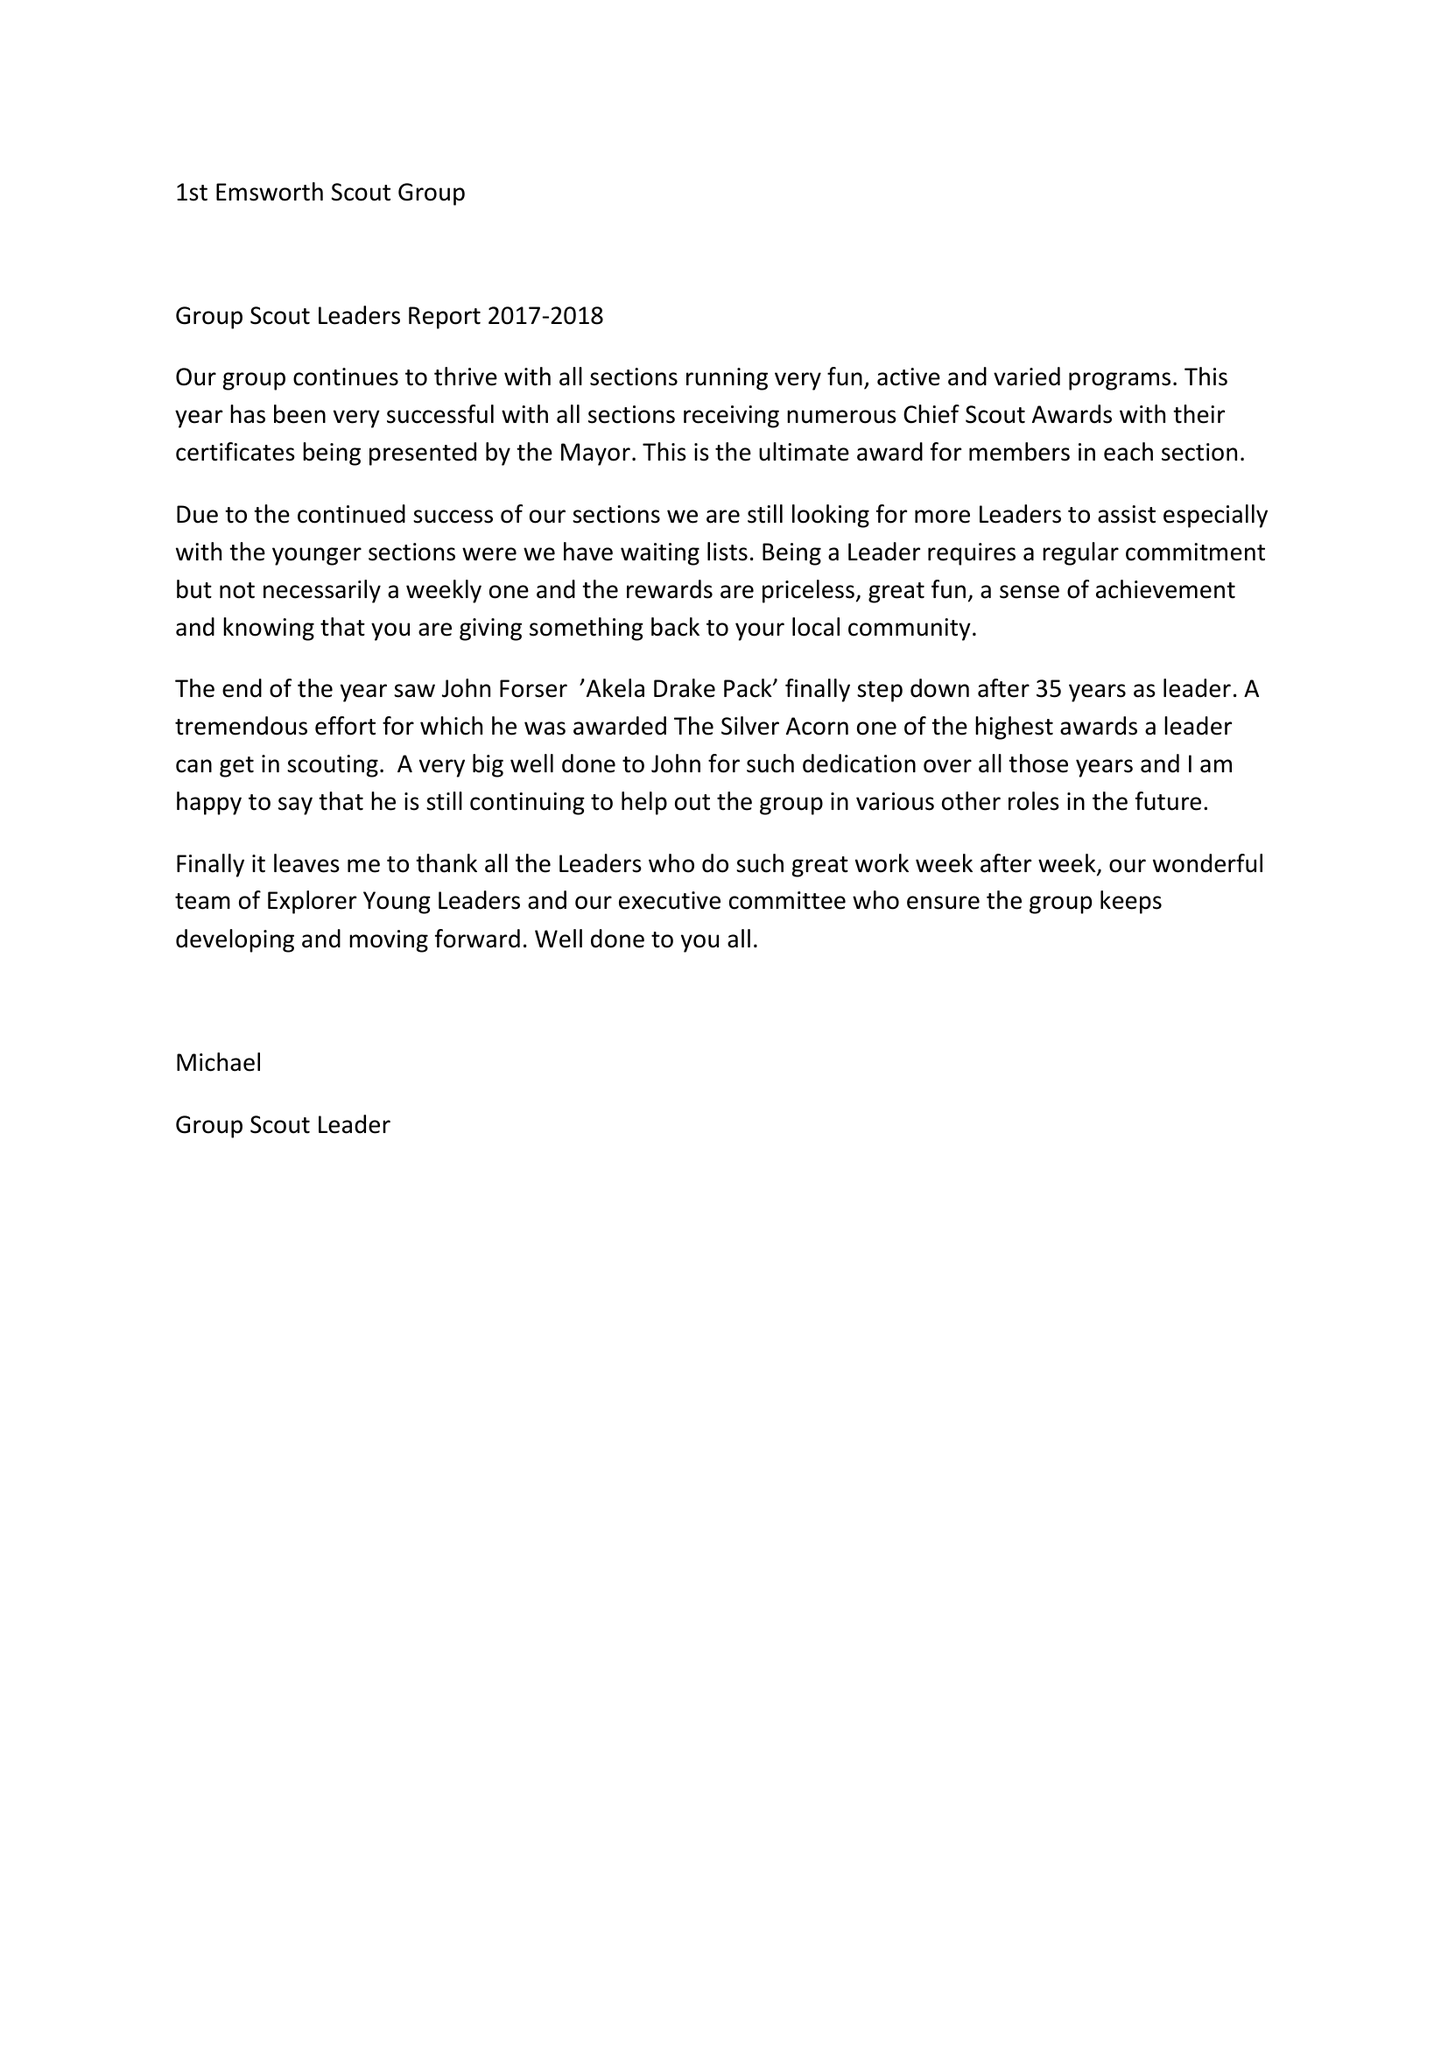What is the value for the address__street_line?
Answer the question using a single word or phrase. 8 SPINNAKER GRANGE 